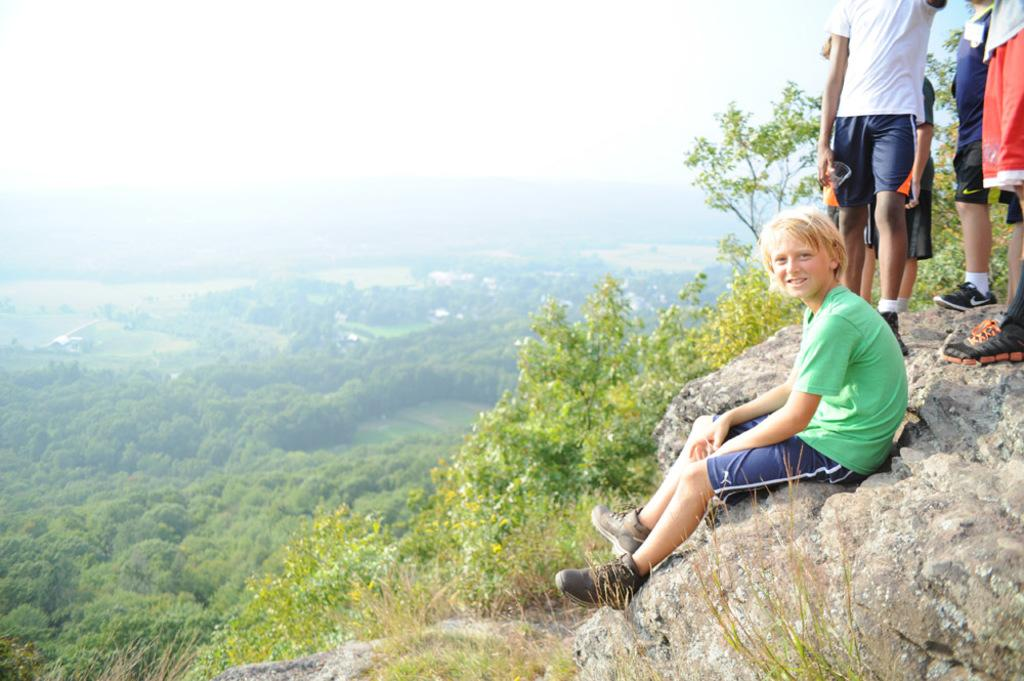What is the boy doing in the image? The boy is sitting on the top of the mountain in the image. Are there any other people in the image? Yes, there are people standing on the mountain in the image. What can be seen in the background of the image? There are trees in the background of the image. What type of ornament is hanging from the boy's neck in the image? There is no ornament visible around the boy's neck in the image. Can you see a kite flying in the sky in the image? There is no kite visible in the sky in the image. 